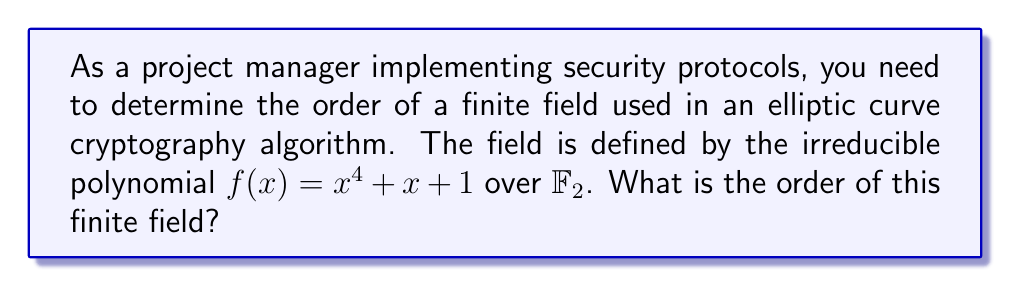Help me with this question. To determine the order of the finite field, we need to follow these steps:

1) The field is defined over $\mathbb{F}_2$, which means the base field has 2 elements (0 and 1).

2) The polynomial $f(x) = x^4 + x + 1$ is of degree 4.

3) For a finite field $\mathbb{F}_{p^n}$ where $p$ is prime and $n$ is the degree of the irreducible polynomial:
   
   The order of the field is $p^n$

4) In this case:
   $p = 2$ (as it's over $\mathbb{F}_2$)
   $n = 4$ (degree of $f(x)$)

5) Therefore, the order of the field is:

   $2^4 = 16$

This means the finite field has 16 elements, which can be represented as polynomials of degree less than 4 over $\mathbb{F}_2$, with addition and multiplication performed modulo $f(x)$.
Answer: 16 